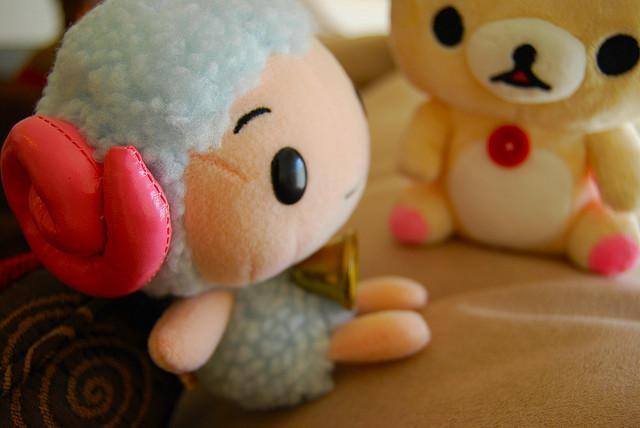How many dolls are there?
Give a very brief answer. 2. How many teddy bears are in the picture?
Give a very brief answer. 2. How many people are in the picture?
Give a very brief answer. 0. 